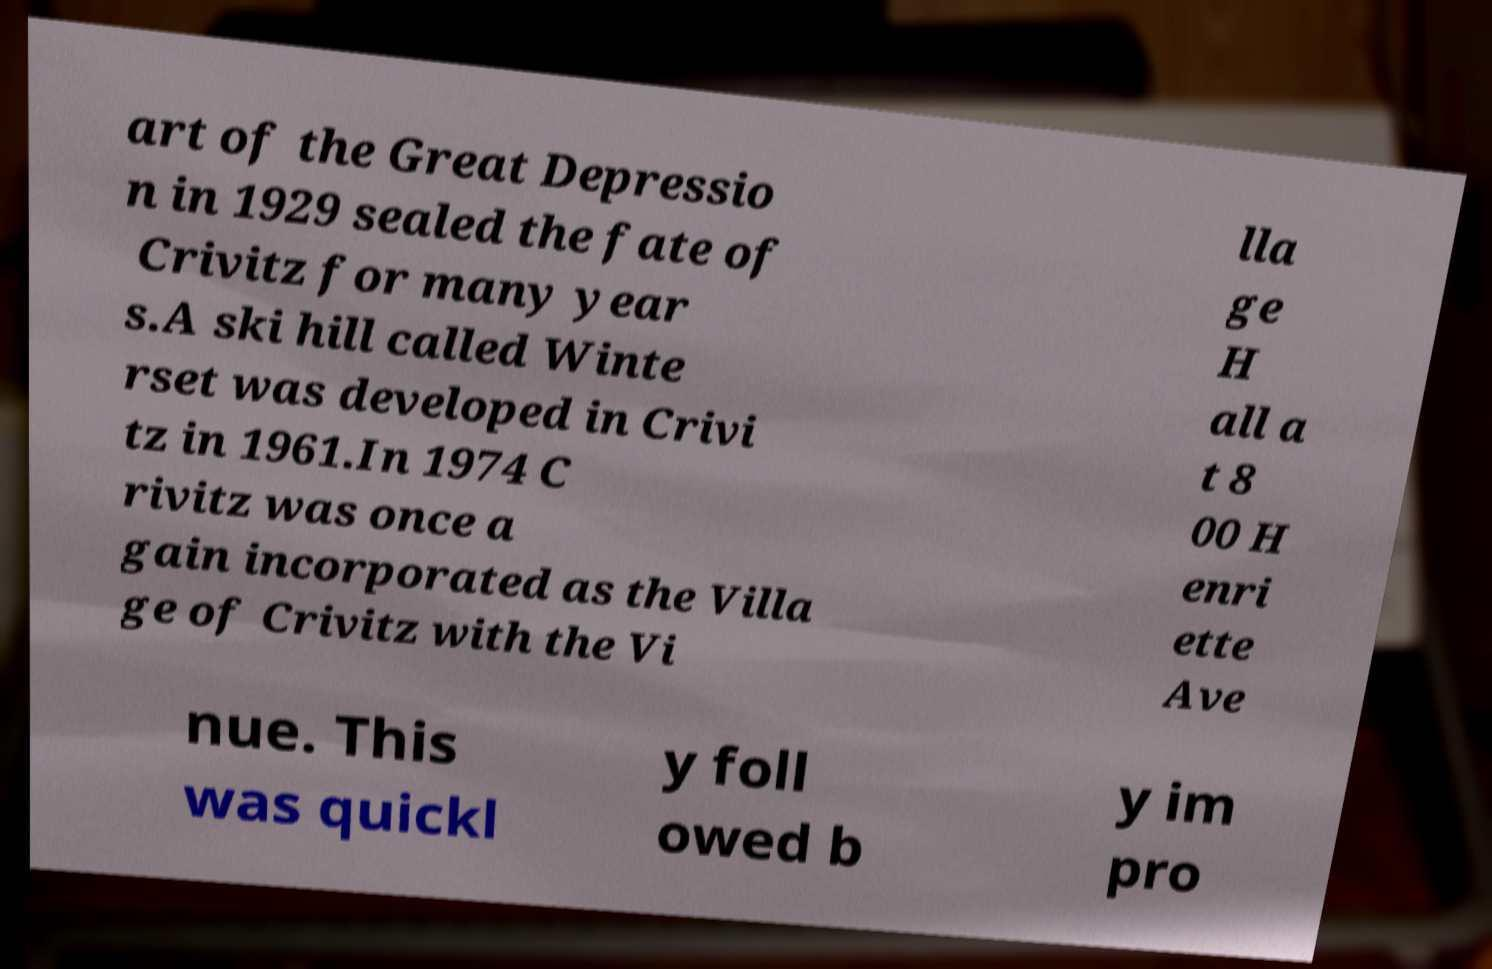Can you read and provide the text displayed in the image?This photo seems to have some interesting text. Can you extract and type it out for me? art of the Great Depressio n in 1929 sealed the fate of Crivitz for many year s.A ski hill called Winte rset was developed in Crivi tz in 1961.In 1974 C rivitz was once a gain incorporated as the Villa ge of Crivitz with the Vi lla ge H all a t 8 00 H enri ette Ave nue. This was quickl y foll owed b y im pro 